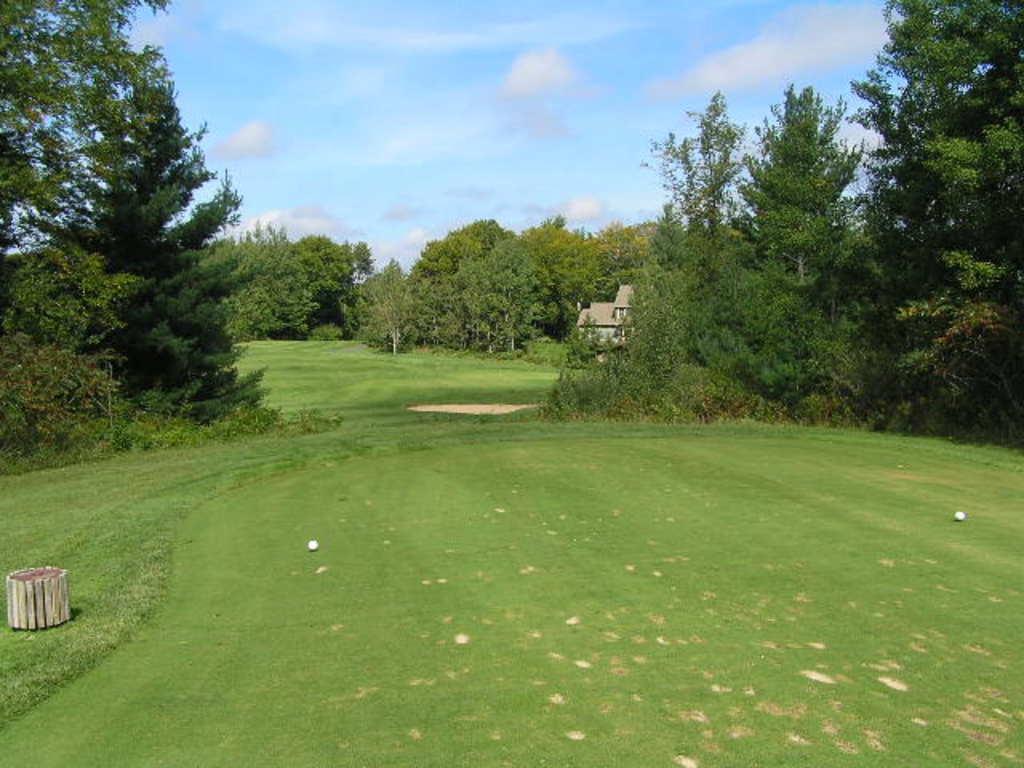Describe this image in one or two sentences. In this image we can see many trees. We can also see two balls, an object on the left and also a house. At the top there is sky with some clouds and at the bottom there is grass. 